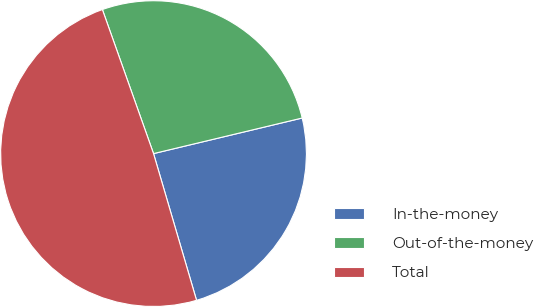<chart> <loc_0><loc_0><loc_500><loc_500><pie_chart><fcel>In-the-money<fcel>Out-of-the-money<fcel>Total<nl><fcel>24.2%<fcel>26.69%<fcel>49.11%<nl></chart> 